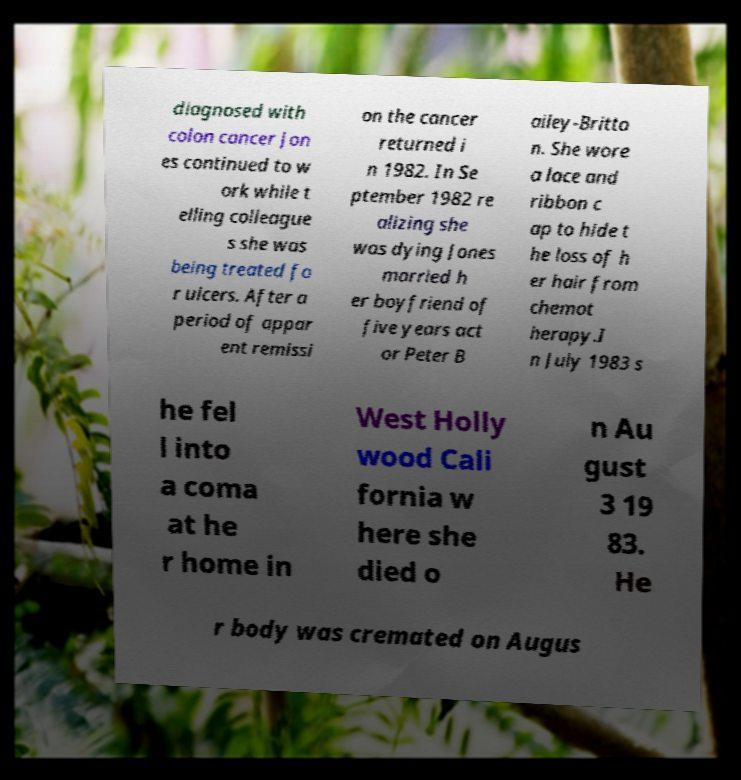Can you read and provide the text displayed in the image?This photo seems to have some interesting text. Can you extract and type it out for me? diagnosed with colon cancer Jon es continued to w ork while t elling colleague s she was being treated fo r ulcers. After a period of appar ent remissi on the cancer returned i n 1982. In Se ptember 1982 re alizing she was dying Jones married h er boyfriend of five years act or Peter B ailey-Britto n. She wore a lace and ribbon c ap to hide t he loss of h er hair from chemot herapy.I n July 1983 s he fel l into a coma at he r home in West Holly wood Cali fornia w here she died o n Au gust 3 19 83. He r body was cremated on Augus 